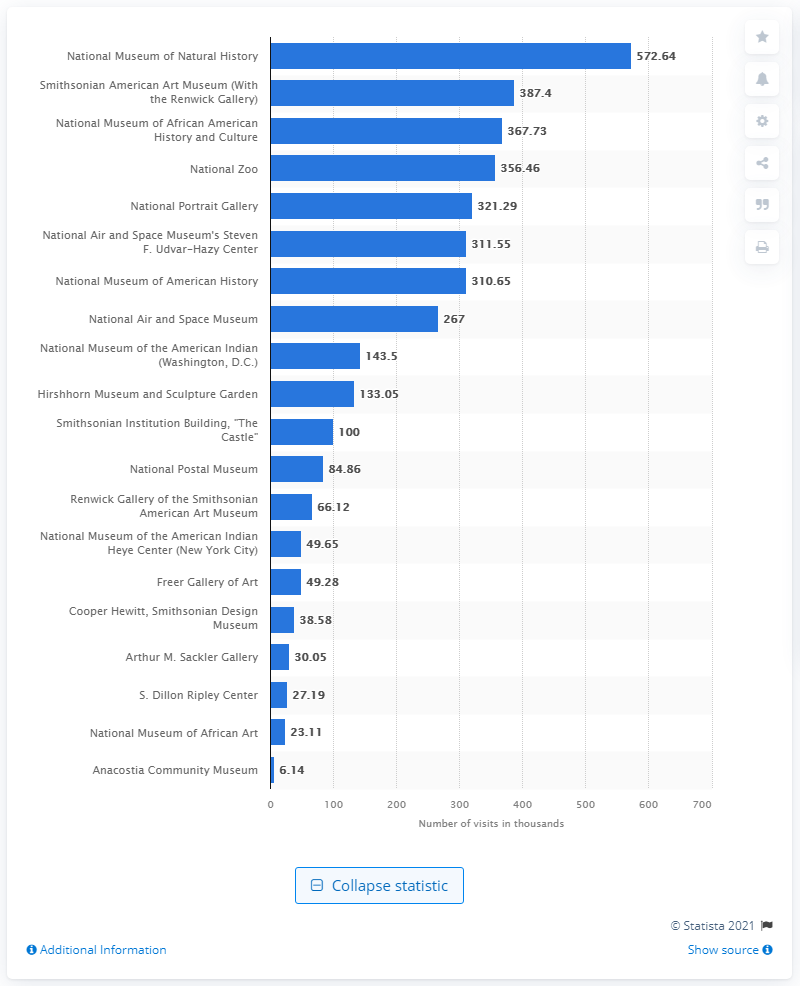Outline some significant characteristics in this image. According to data from 2020, the National Museum of Natural History was the most visited Smithsonian museum in the United States. In 2020, the Smithsonian museum that attracted the most visitors in the United States was the National Museum of Natural History. 